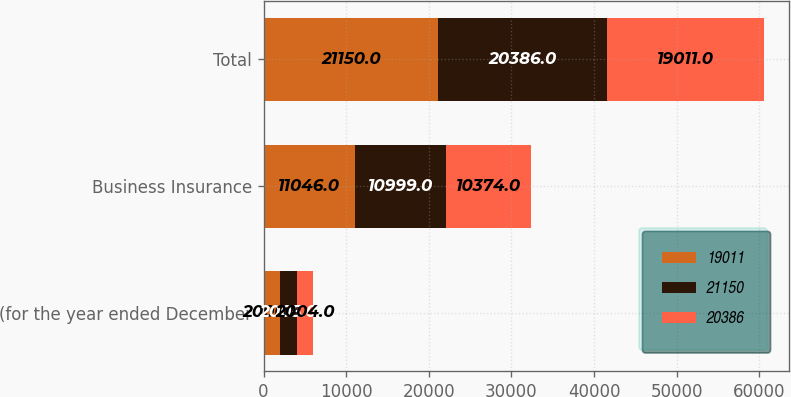Convert chart. <chart><loc_0><loc_0><loc_500><loc_500><stacked_bar_chart><ecel><fcel>(for the year ended December<fcel>Business Insurance<fcel>Total<nl><fcel>19011<fcel>2006<fcel>11046<fcel>21150<nl><fcel>21150<fcel>2005<fcel>10999<fcel>20386<nl><fcel>20386<fcel>2004<fcel>10374<fcel>19011<nl></chart> 